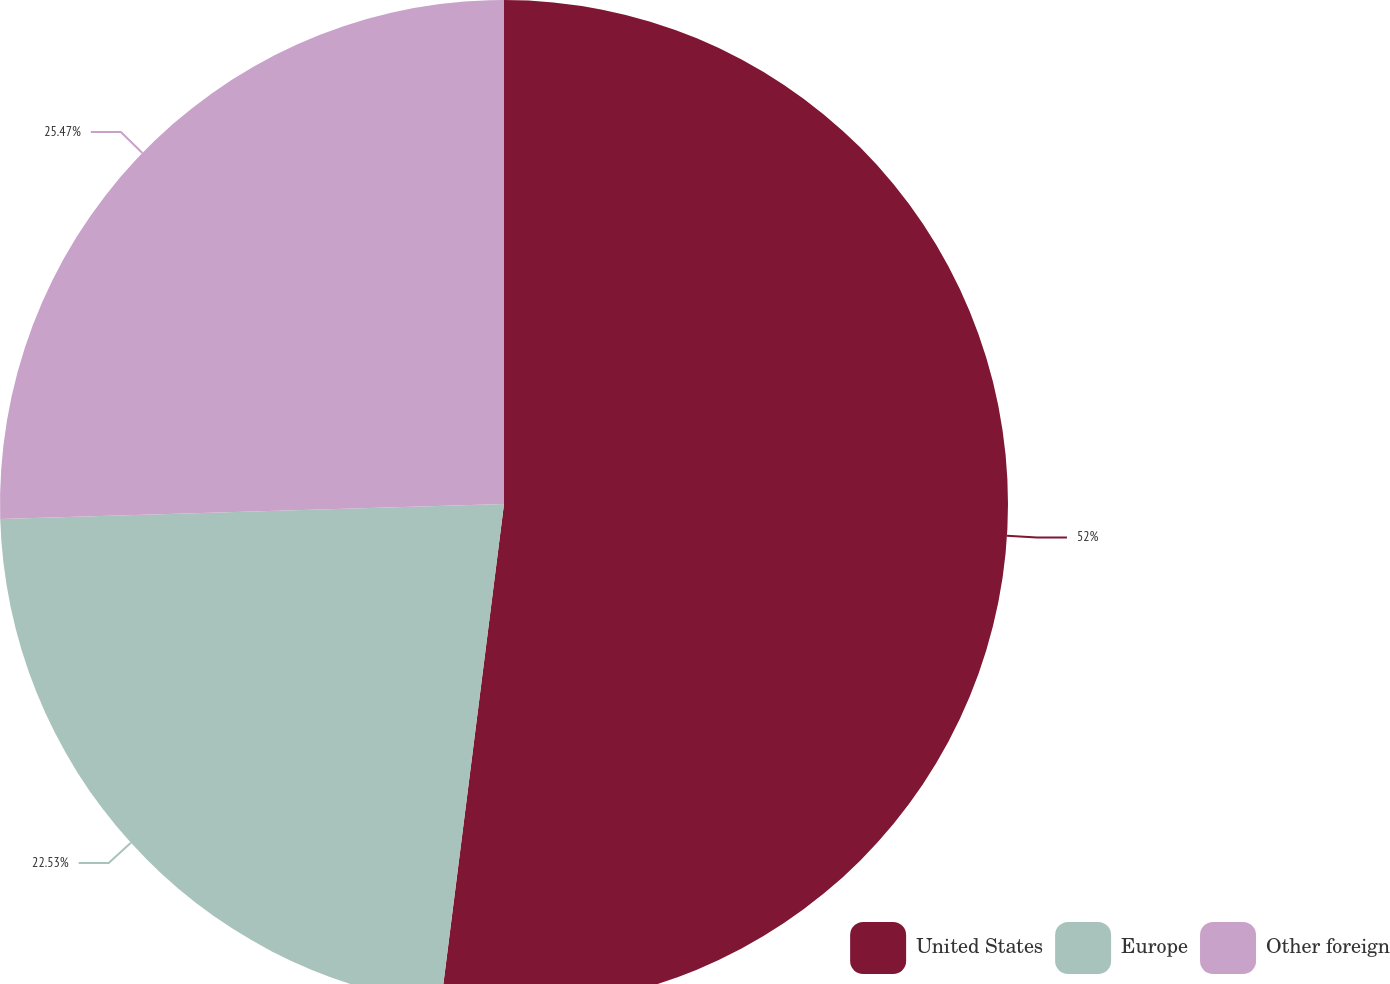Convert chart. <chart><loc_0><loc_0><loc_500><loc_500><pie_chart><fcel>United States<fcel>Europe<fcel>Other foreign<nl><fcel>52.0%<fcel>22.53%<fcel>25.47%<nl></chart> 